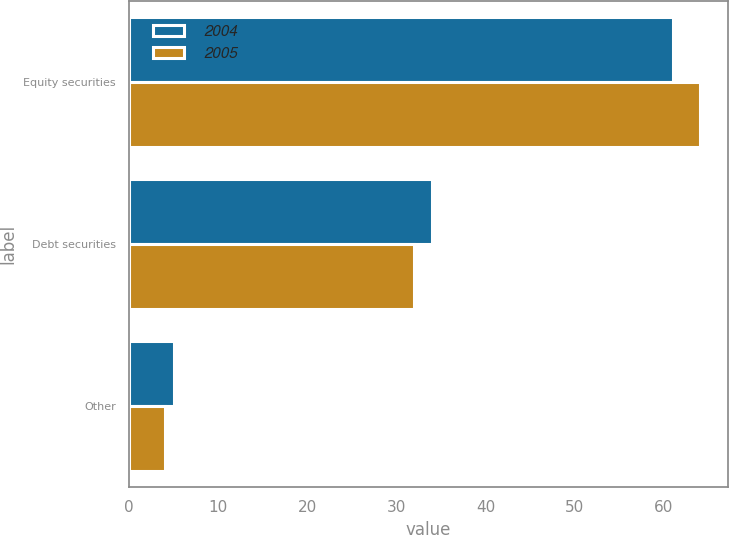<chart> <loc_0><loc_0><loc_500><loc_500><stacked_bar_chart><ecel><fcel>Equity securities<fcel>Debt securities<fcel>Other<nl><fcel>2004<fcel>61<fcel>34<fcel>5<nl><fcel>2005<fcel>64<fcel>32<fcel>4<nl></chart> 